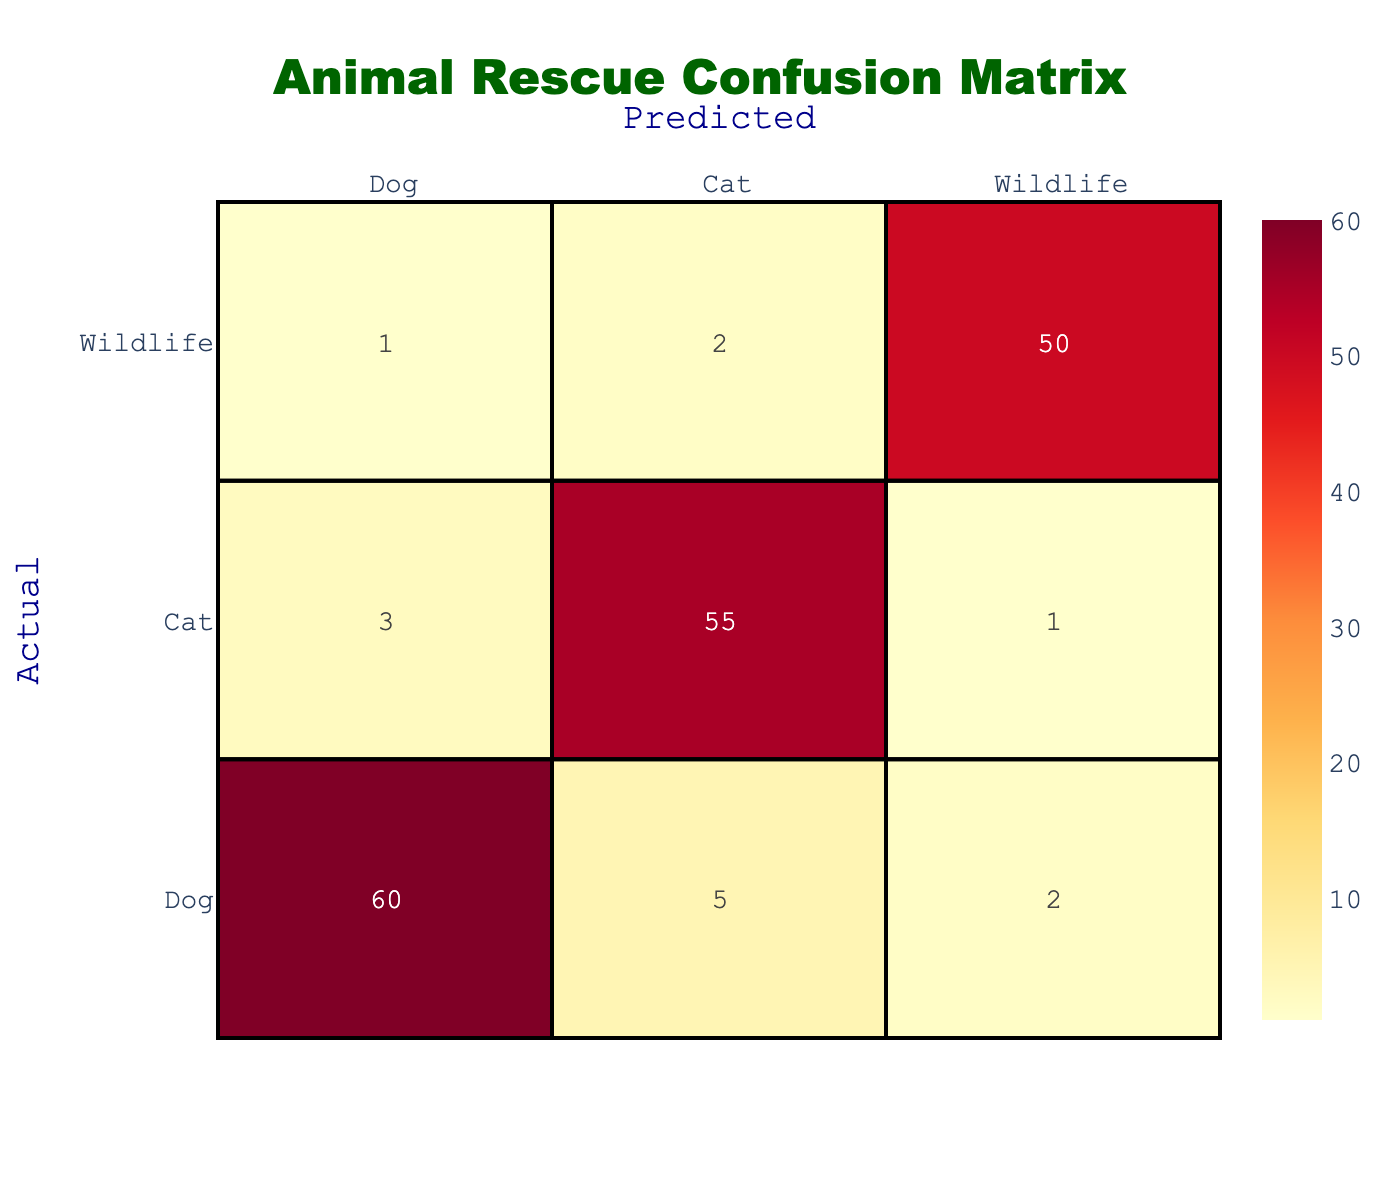What is the predicted count of dogs that were actually dogs? Under the "Dog" row and "Dog" column, the table shows the value 60, which represents the predicted count of dogs that were categorized correctly as dogs.
Answer: 60 How many wildlife animals were misclassified as dogs? In the "Wildlife" row and "Dog" column, the table shows the value 1. This indicates that 1 wildlife animal was incorrectly predicted to be a dog.
Answer: 1 What is the total number of cats rescued? To find this, we look at the "Cat" row and sum the values across the columns: 3 (predicted as dogs) + 55 (predicted as cats) + 1 (predicted as wildlife) = 59. Thus, the total number of cats rescued is 59.
Answer: 59 What percentage of the total wildlife animals were predicted correctly? The total number of wildlife animals rescued is the sum of the "Wildlife" row: 1 (misclassified as dogs) + 2 (misclassified as cats) + 50 (predicted as wildlife) = 53. Out of these, 50 were predicted correctly. The percentage is (50/53) * 100 ≈ 94.34%.
Answer: Approximately 94.34% Is it true that more cats were correctly identified than dogs? The correctly identified cats are 55 (in the "Cat" row), while the correctly identified dogs are 60 (in the "Dog" row). Since 55 is less than 60, the statement is false.
Answer: No How many more dogs were accurately predicted compared to wildlife? The correctly predicted dogs are 60, and the correctly predicted wildlife is 50. The difference is 60 - 50 = 10, meaning there were 10 more accurately predicted dogs than wildlife animals.
Answer: 10 What is the total number of animals that were misclassified? To find this, we sum all the off-diagonal entries of the confusion matrix: 5 (cats as dogs) + 2 (wildlife as dogs) + 3 (dogs as cats) + 1 (wildlife as cats) + 1 (dogs as wildlife) + 2 (cats as wildlife) = 14. Hence, the total number of misclassified animals is 14.
Answer: 14 How many total animals were predicted as cats? Looking at the "Cat" column, we add the values: 5 (predicted as dogs) + 55 (predicted as cats) + 2 (predicted as wildlife) = 62. Therefore, the total number of animals predicted as cats is 62.
Answer: 62 Which species had the highest number of predictions? To determine this, we sum the values for each species. Dogs: 60 + 5 + 2 = 67, Cats: 3 + 55 + 1 = 59, Wildlife: 1 + 2 + 50 = 53. Since 67 is the highest, dogs had the most predictions.
Answer: Dogs 